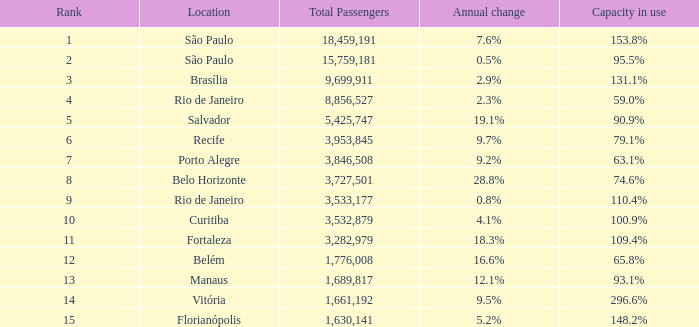What site undergoes an annual fluctuation of São Paulo. 